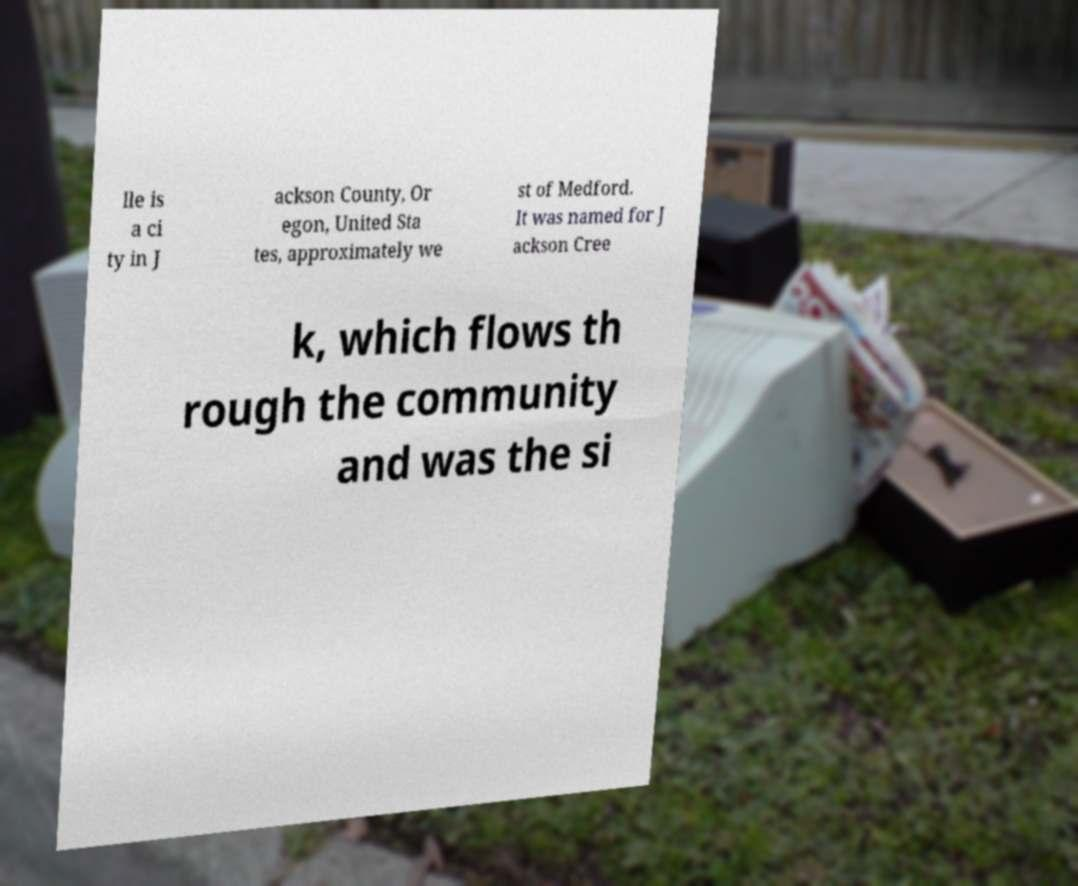Please identify and transcribe the text found in this image. lle is a ci ty in J ackson County, Or egon, United Sta tes, approximately we st of Medford. It was named for J ackson Cree k, which flows th rough the community and was the si 